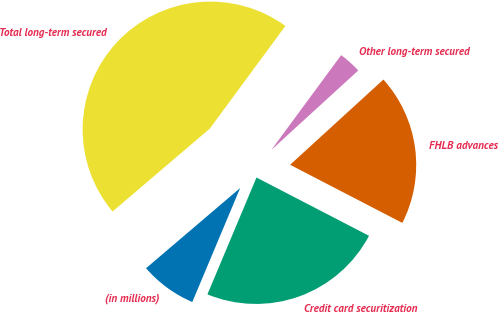<chart> <loc_0><loc_0><loc_500><loc_500><pie_chart><fcel>(in millions)<fcel>Credit card securitization<fcel>FHLB advances<fcel>Other long-term secured<fcel>Total long-term secured<nl><fcel>7.44%<fcel>23.72%<fcel>19.39%<fcel>3.11%<fcel>46.34%<nl></chart> 